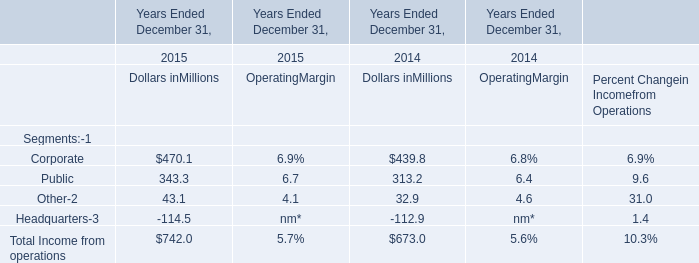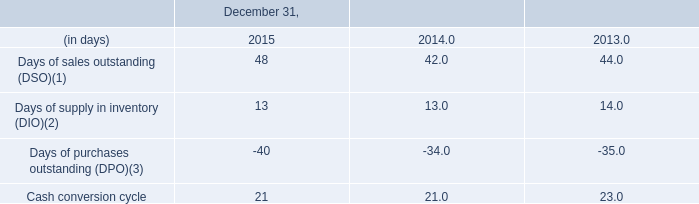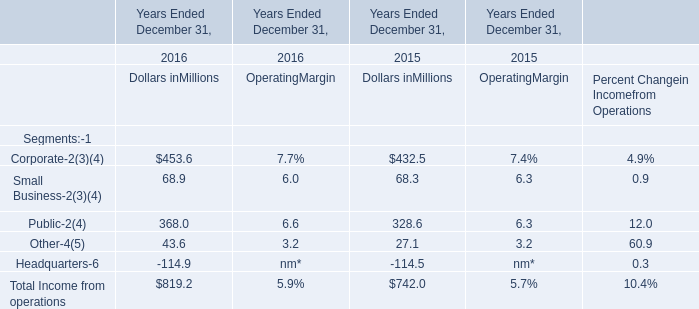what was the approximate value of kelway in the fourth quarter of 2014 , in millions? 
Computations: ((100 / 35) * 86.8)
Answer: 248.0. 